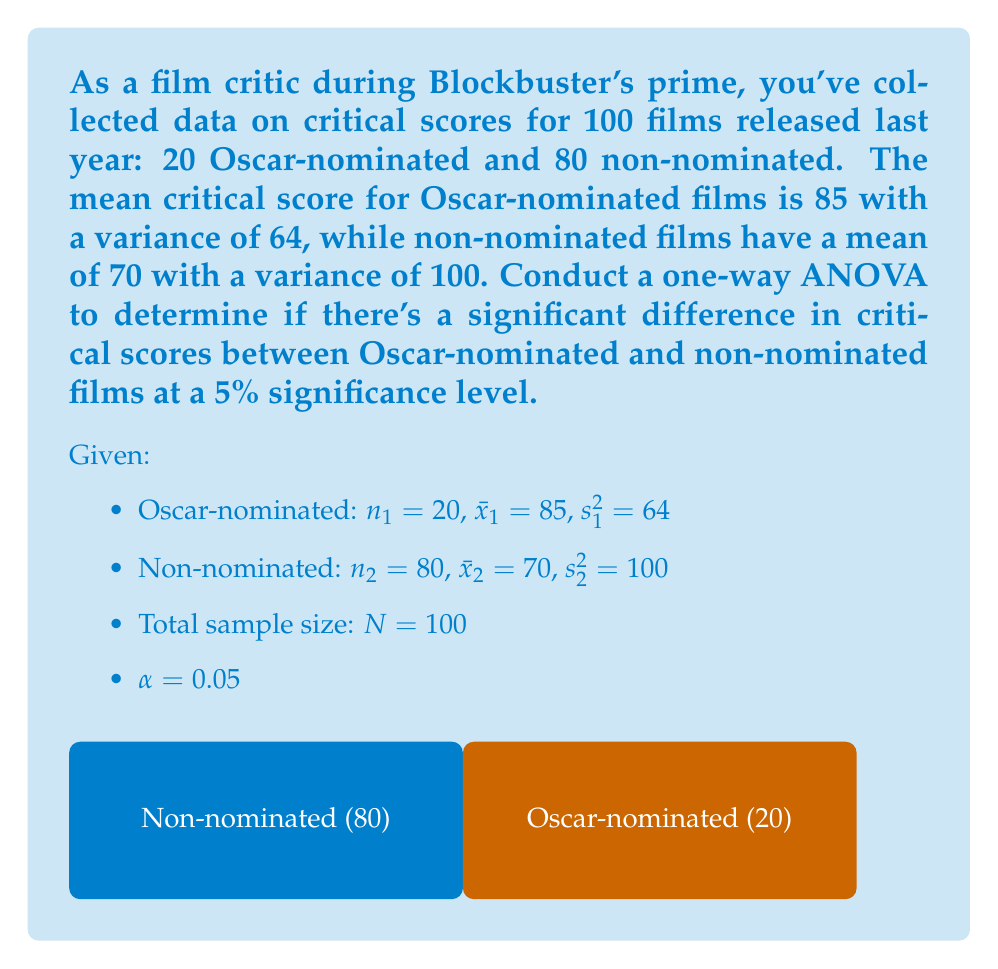What is the answer to this math problem? 1) Calculate the Sum of Squares Between (SSB):
   $$SSB = \sum_{i=1}^k n_i(\bar{x}_i - \bar{x})^2$$
   First, find the grand mean: $\bar{x} = \frac{20(85) + 80(70)}{100} = 73$
   $$SSB = 20(85-73)^2 + 80(70-73)^2 = 4320$$

2) Calculate the Sum of Squares Within (SSW):
   $$SSW = \sum_{i=1}^k (n_i - 1)s_i^2$$
   $$SSW = 19(64) + 79(100) = 9116$$

3) Calculate the Sum of Squares Total (SST):
   $$SST = SSB + SSW = 4320 + 9116 = 13436$$

4) Calculate degrees of freedom:
   $df_{between} = k - 1 = 2 - 1 = 1$
   $df_{within} = N - k = 100 - 2 = 98$
   $df_{total} = N - 1 = 99$

5) Calculate Mean Squares:
   $$MS_{between} = \frac{SSB}{df_{between}} = \frac{4320}{1} = 4320$$
   $$MS_{within} = \frac{SSW}{df_{within}} = \frac{9116}{98} = 93.02$$

6) Calculate F-statistic:
   $$F = \frac{MS_{between}}{MS_{within}} = \frac{4320}{93.02} = 46.44$$

7) Find critical F-value:
   $F_{critical} = F_{0.05,1,98} = 3.94$ (from F-distribution table)

8) Decision:
   Since $F = 46.44 > F_{critical} = 3.94$, we reject the null hypothesis.
Answer: $F(1,98) = 46.44, p < 0.05$. Significant difference exists. 